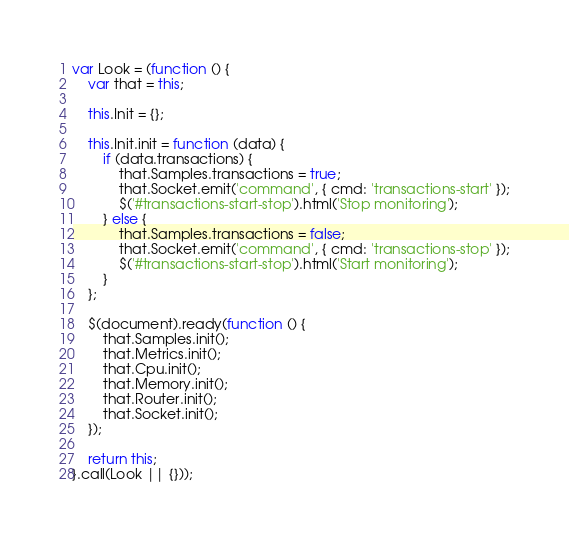Convert code to text. <code><loc_0><loc_0><loc_500><loc_500><_JavaScript_>var Look = (function () {
    var that = this;

    this.Init = {};

    this.Init.init = function (data) {
        if (data.transactions) {
            that.Samples.transactions = true;
            that.Socket.emit('command', { cmd: 'transactions-start' });
            $('#transactions-start-stop').html('Stop monitoring');
        } else {
            that.Samples.transactions = false;
            that.Socket.emit('command', { cmd: 'transactions-stop' });
            $('#transactions-start-stop').html('Start monitoring');
        }
    };

    $(document).ready(function () {
        that.Samples.init();
        that.Metrics.init();
        that.Cpu.init();
        that.Memory.init();
        that.Router.init();
        that.Socket.init();
    });

    return this;
}.call(Look || {}));</code> 